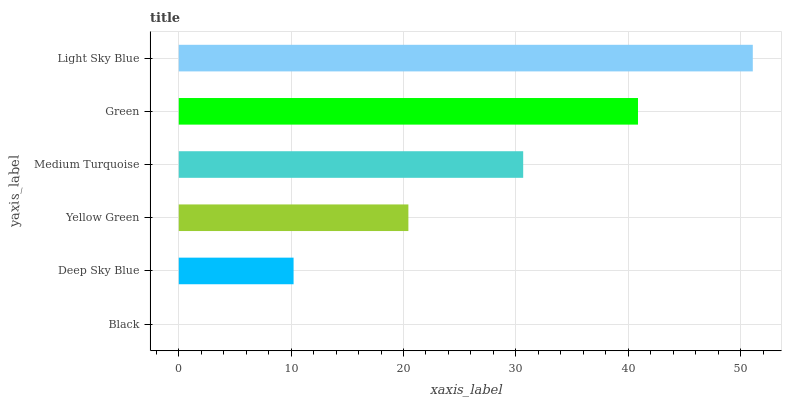Is Black the minimum?
Answer yes or no. Yes. Is Light Sky Blue the maximum?
Answer yes or no. Yes. Is Deep Sky Blue the minimum?
Answer yes or no. No. Is Deep Sky Blue the maximum?
Answer yes or no. No. Is Deep Sky Blue greater than Black?
Answer yes or no. Yes. Is Black less than Deep Sky Blue?
Answer yes or no. Yes. Is Black greater than Deep Sky Blue?
Answer yes or no. No. Is Deep Sky Blue less than Black?
Answer yes or no. No. Is Medium Turquoise the high median?
Answer yes or no. Yes. Is Yellow Green the low median?
Answer yes or no. Yes. Is Light Sky Blue the high median?
Answer yes or no. No. Is Deep Sky Blue the low median?
Answer yes or no. No. 